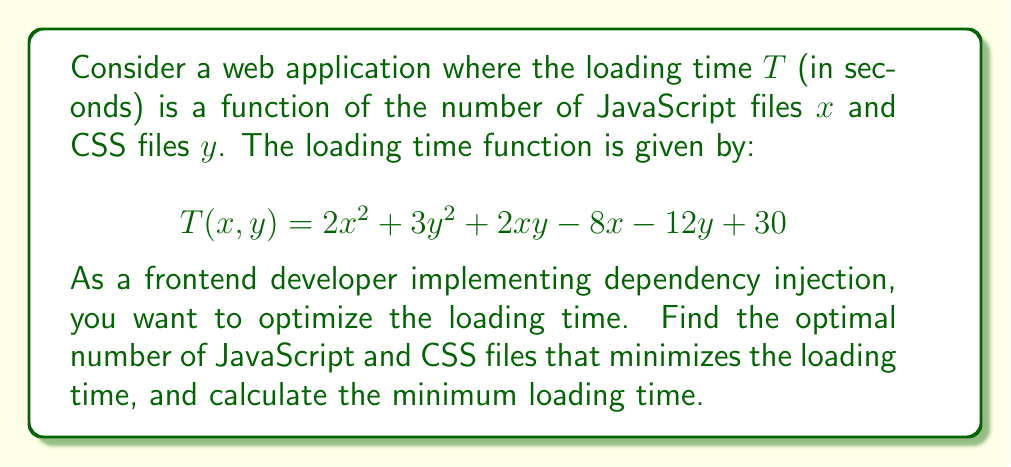Provide a solution to this math problem. To find the optimal number of files and minimize the loading time, we need to find the critical points of the function $T(x,y)$ and evaluate them.

Step 1: Calculate the partial derivatives of $T$ with respect to $x$ and $y$:
$$\frac{\partial T}{\partial x} = 4x + 2y - 8$$
$$\frac{\partial T}{\partial y} = 6y + 2x - 12$$

Step 2: Set both partial derivatives to zero to find the critical points:
$$4x + 2y - 8 = 0 \quad (1)$$
$$6y + 2x - 12 = 0 \quad (2)$$

Step 3: Solve the system of equations:
Multiply equation (1) by 3 and equation (2) by 2:
$$12x + 6y - 24 = 0 \quad (3)$$
$$12y + 4x - 24 = 0 \quad (4)$$

Subtract equation (4) from (3):
$$8x - 6y = 0$$
$$4x = 3y$$
$$x = \frac{3y}{4}$$

Substitute this into equation (1):
$$4(\frac{3y}{4}) + 2y - 8 = 0$$
$$3y + 2y - 8 = 0$$
$$5y = 8$$
$$y = \frac{8}{5} = 1.6$$

Now we can find $x$:
$$x = \frac{3y}{4} = \frac{3(8/5)}{4} = \frac{24}{20} = \frac{6}{5} = 1.2$$

Step 4: Verify that this critical point is a minimum by checking the second partial derivatives:
$$\frac{\partial^2 T}{\partial x^2} = 4 > 0$$
$$\frac{\partial^2 T}{\partial y^2} = 6 > 0$$
$$\frac{\partial^2 T}{\partial x \partial y} = \frac{\partial^2 T}{\partial y \partial x} = 2$$

The determinant of the Hessian matrix is:
$$4 \cdot 6 - 2^2 = 20 > 0$$

Since both second partial derivatives are positive and the determinant of the Hessian is positive, this critical point is a local minimum.

Step 5: Calculate the minimum loading time:
$$T(1.2, 1.6) = 2(1.2)^2 + 3(1.6)^2 + 2(1.2)(1.6) - 8(1.2) - 12(1.6) + 30$$
$$= 2.88 + 7.68 + 3.84 - 9.6 - 19.2 + 30$$
$$= 15.6$$
Answer: Optimal files: $x \approx 1.2$ (JavaScript), $y \approx 1.6$ (CSS); Minimum loading time: $15.6$ seconds 